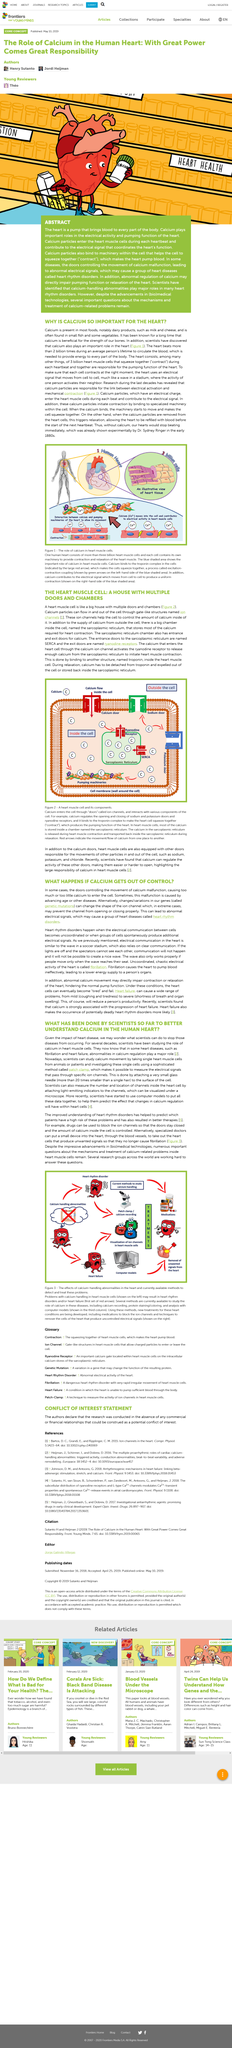Outline some significant characteristics in this image. Scientists have made significant progress in their efforts to better understand the role of calcium in the human heart, as evidenced by the headline of this article, which asks, "What has been done by scientists so far to better understand calcium in the human heart?" The function of ion channels is to regulate the amount of calcium in heart muscle cells by allowing the movement of ions across cell membranes. The human heart contains three billion muscle cells, playing a crucial role in the heart's ability to pump blood throughout the body. The heart beats approximately 2 billion times over the course of a human lifetime. The heart muscle cell is often represented using the analogy of a house with multiple doors and chambers, which provides a useful framework for understanding its structure and function. 